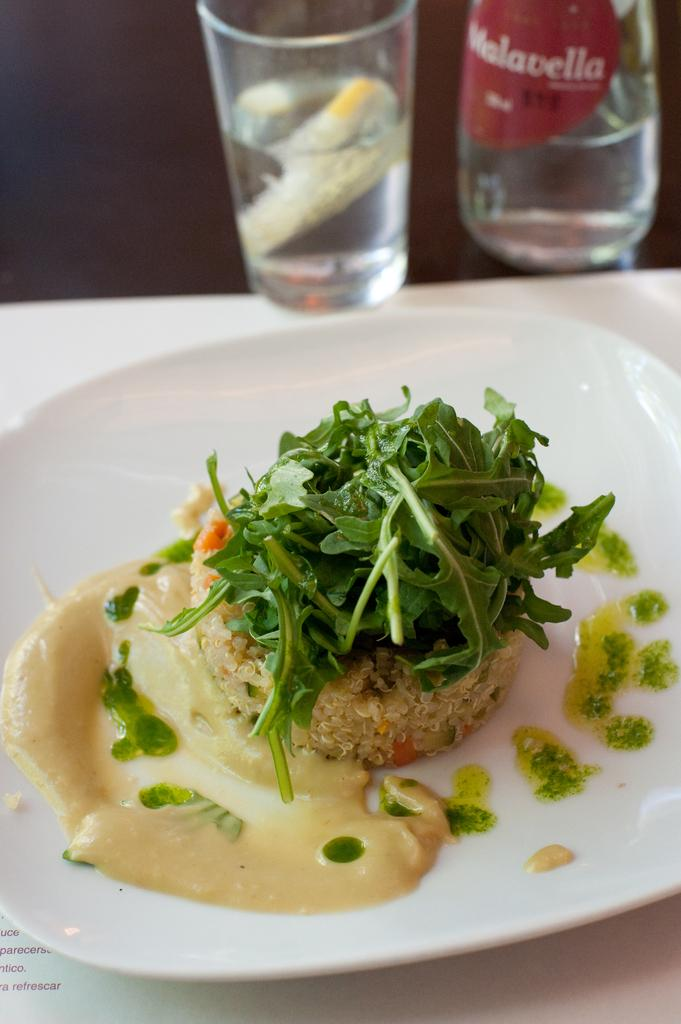<image>
Share a concise interpretation of the image provided. A Malavella brand beverage sits behind a delicious appetizer. 